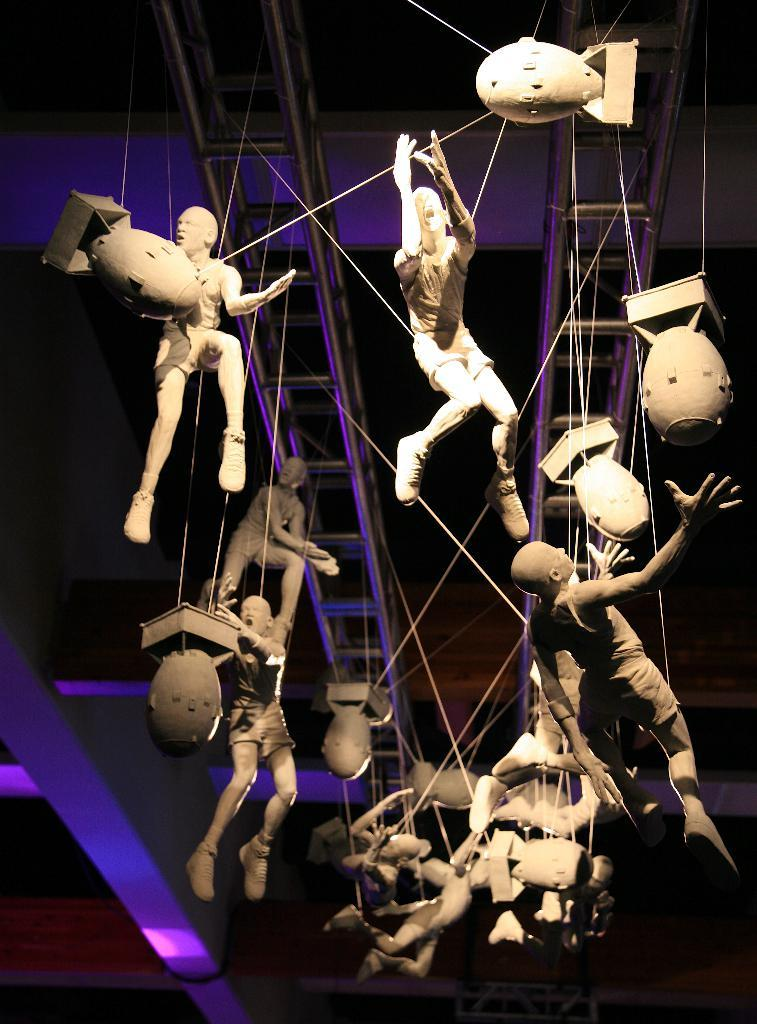What is the main subject of the image? There is a group of statues in the image. How are the statues positioned or connected? The statues are tied with ropes and are on a metal frame. Where is the scene taking place? The scene is inside a building. What can be seen in the background of the image? There are lights visible in the background of the image. What type of behavior can be observed in the statues in the image? The statues are inanimate objects and do not exhibit behavior. How low are the lights in the background of the image? The provided facts do not specify the height or brightness of the lights in the background. 